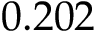<formula> <loc_0><loc_0><loc_500><loc_500>0 . 2 0 2</formula> 